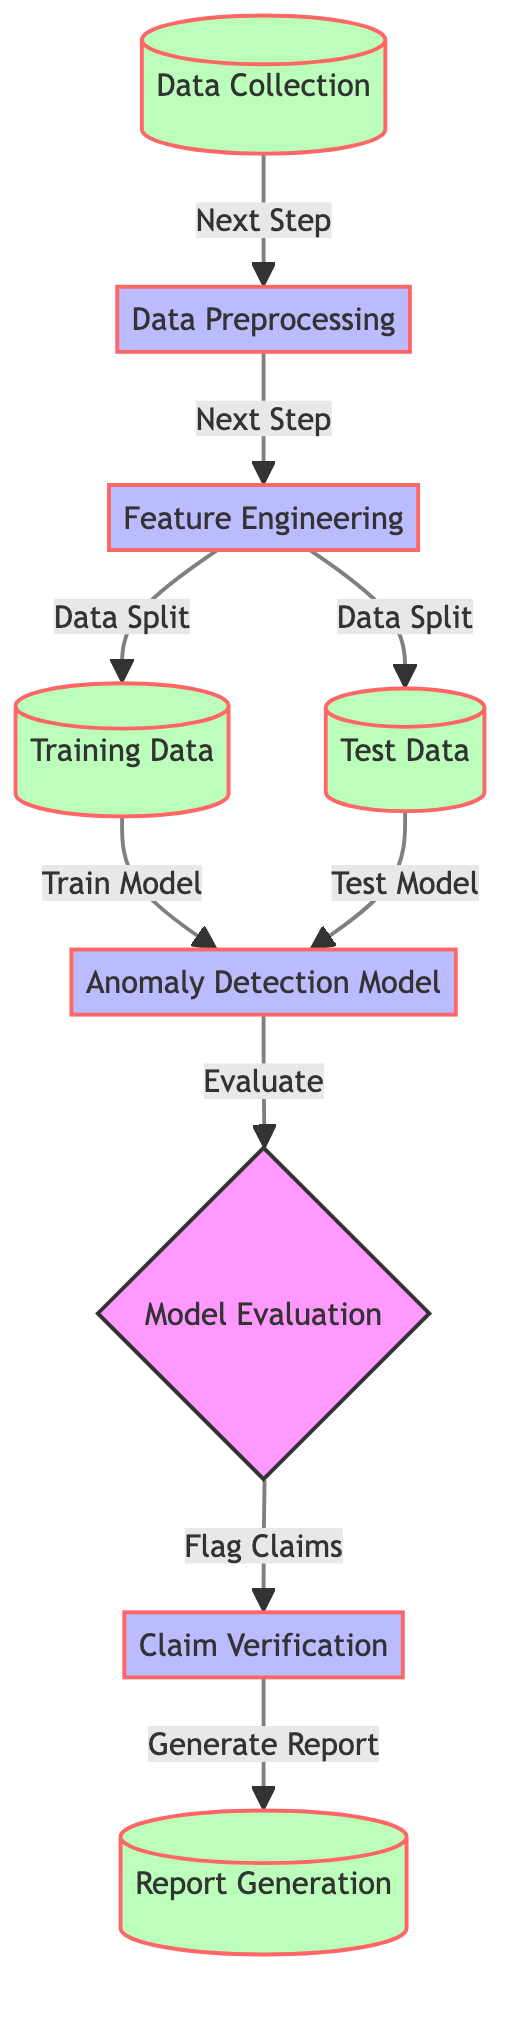What is the first step in the diagram? The diagram begins with the node labeled "Data Collection", indicating that data collection is the initial step in the process.
Answer: Data Collection How many nodes represent the data type in the diagram? The diagram has three nodes representing the data type: "Data Collection", "Training Data", and "Test Data".
Answer: 3 What is the last step in the process? The diagram concludes with the node "Report Generation", which is the final step after all previous processes have been completed.
Answer: Report Generation Which step leads to "Training Data" and "Test Data"? The step "Feature Engineering" leads to both "Training Data" and "Test Data" as indicated by the "Data Split" connection.
Answer: Feature Engineering What does the "Anomaly Detection Model" connect to? The "Anomaly Detection Model" connects to "Model Evaluation" after being trained and tested with the respective data sets.
Answer: Model Evaluation What is the function of "Model Evaluation"? "Model Evaluation" is responsible for evaluating the anomaly detection model’s performance before flagging claims based on the results.
Answer: Evaluate How does the flow proceed from "Claim Verification"? After "Claim Verification", the flow proceeds to "Report Generation", indicating that claims are finalized with a report.
Answer: Report Generation Which action follows after evaluating the model? The action that immediately follows "Model Evaluation" is "Flag Claims", which indicates potential fraudulent claims for further investigation.
Answer: Flag Claims What two processes occur before the "Anomaly Detection Model" is trained? The two processes that occur before training the model are "Data Preprocessing" and "Feature Engineering".
Answer: Data Preprocessing and Feature Engineering 